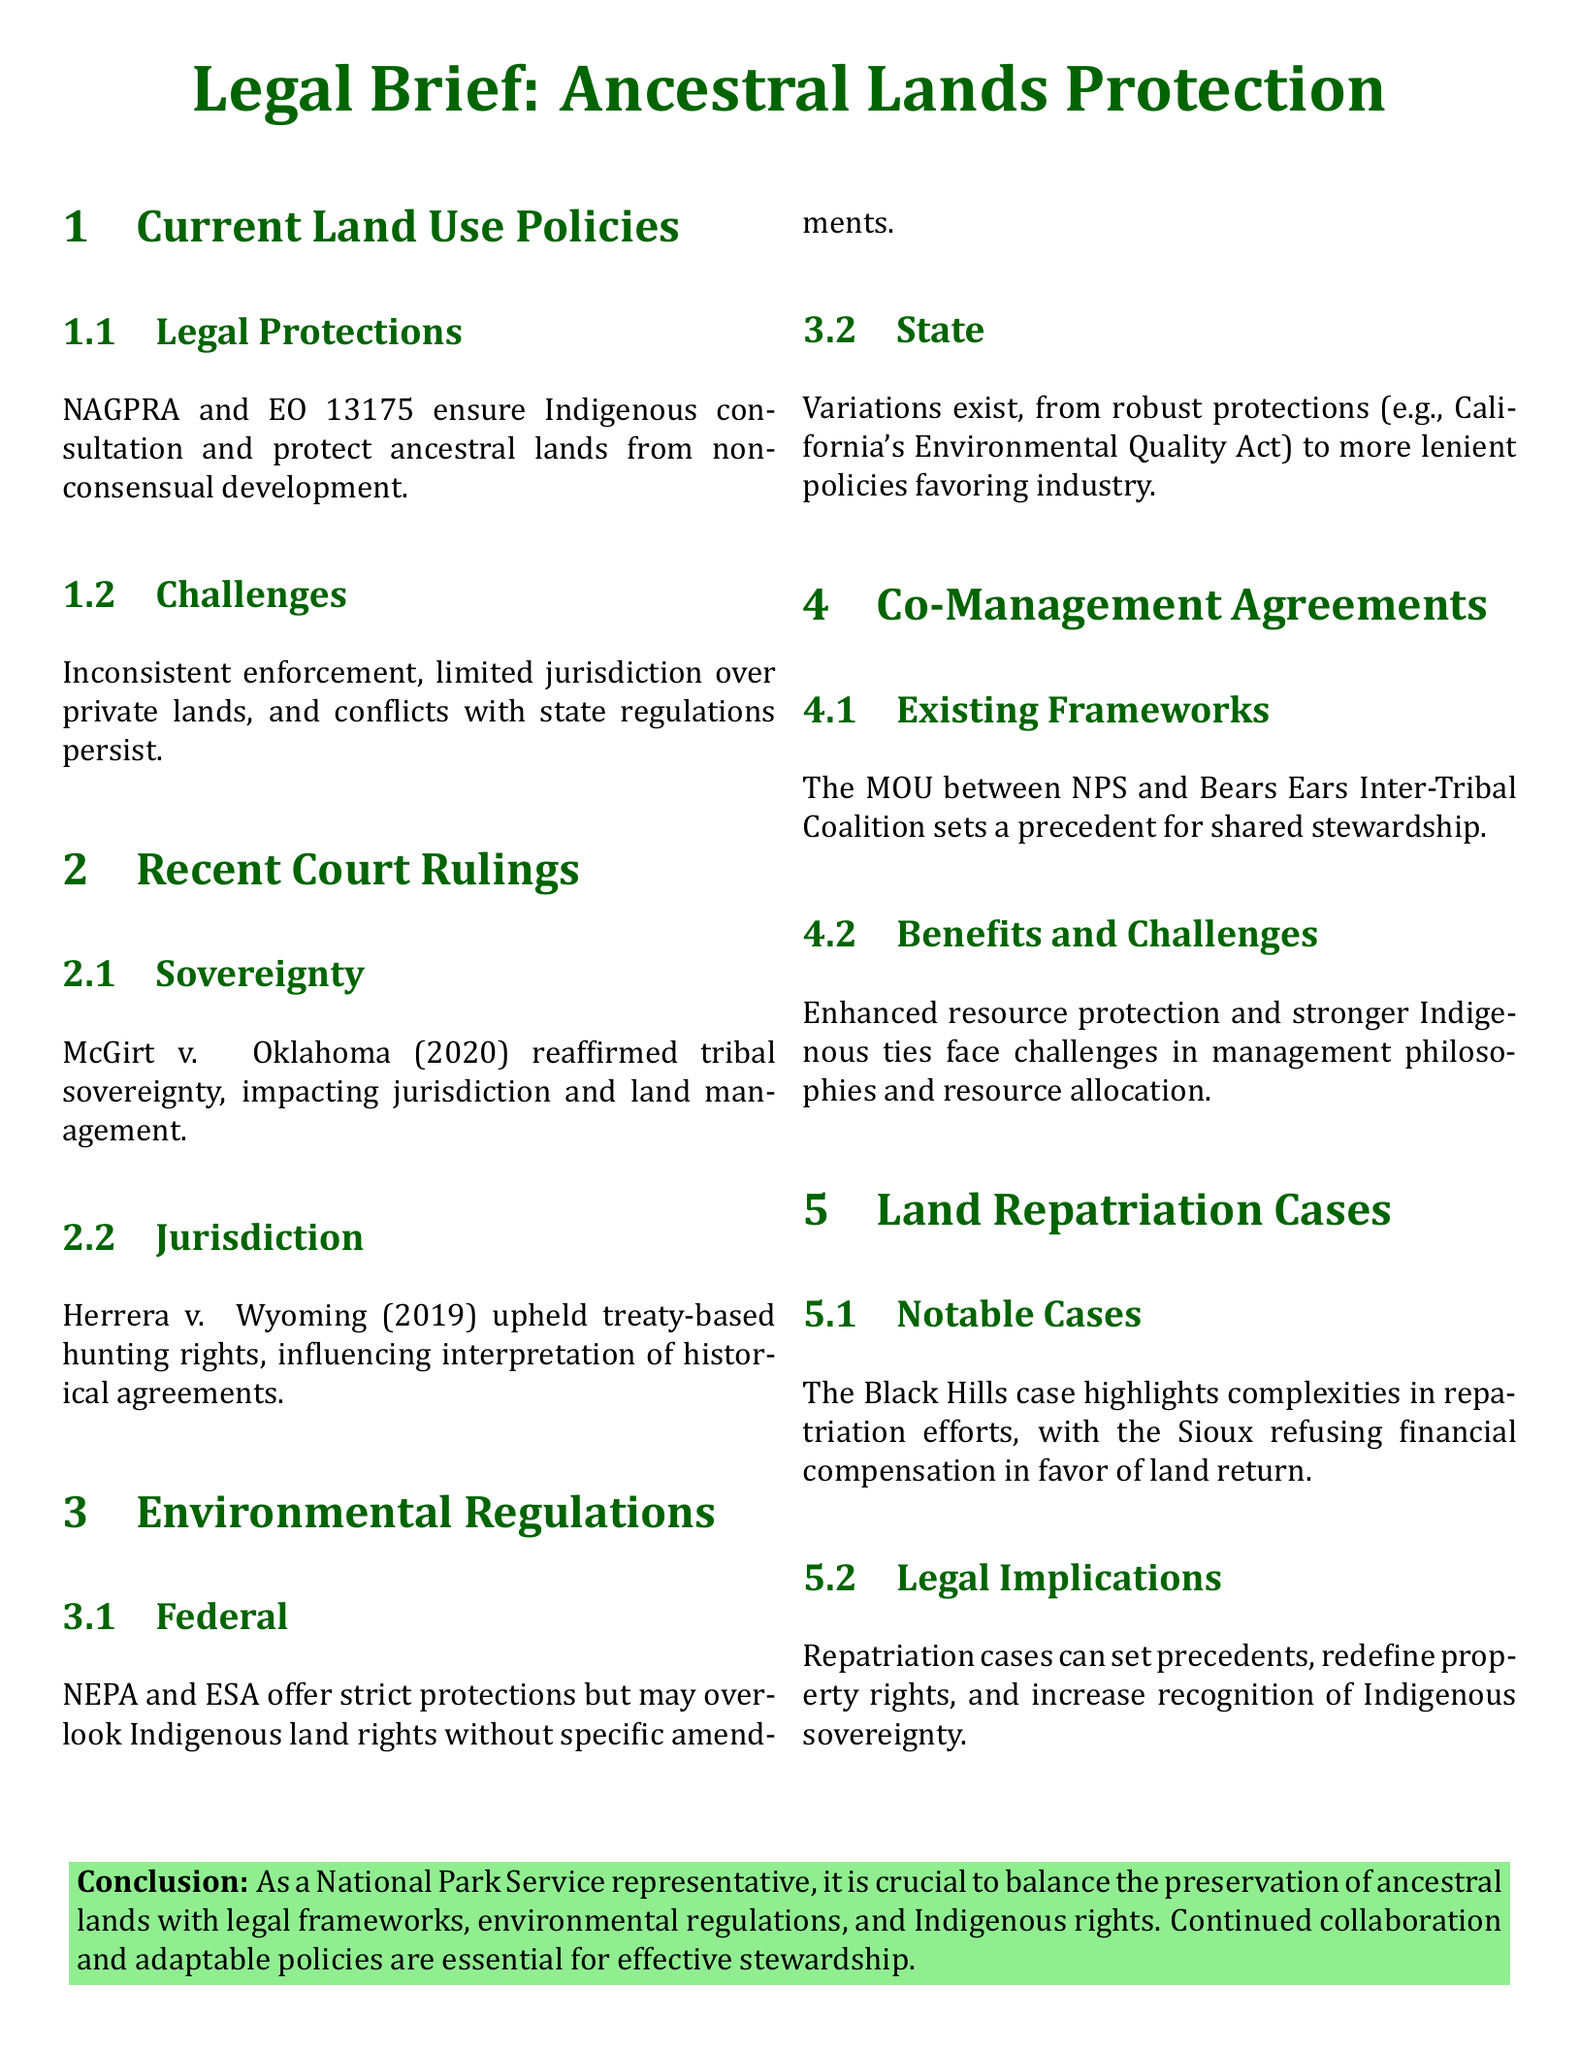What are the two legal frameworks ensuring protection of ancestral lands? The document mentions NAGPRA and EO 13175 as the legal frameworks ensuring protection.
Answer: NAGPRA and EO 13175 What case reaffirmed tribal sovereignty? The document cites McGirt v. Oklahoma (2020) as the case that reaffirmed tribal sovereignty.
Answer: McGirt v. Oklahoma (2020) Which act may overlook Indigenous land rights? The National Environmental Policy Act (NEPA) is noted for potentially overlooking Indigenous land rights without amendments.
Answer: NEPA What is the notable case involving the Black Hills? The Black Hills case is highlighted in the document regarding repatriation efforts.
Answer: Black Hills case What agreement sets a precedent for shared stewardship? The MOU between NPS and Bears Ears Inter-Tribal Coalition is referenced as a precedent for shared stewardship.
Answer: MOU between NPS and Bears Ears Inter-Tribal Coalition What challenge is mentioned regarding co-management agreements? The document mentions challenges in management philosophies and resource allocation relating to co-management agreements.
Answer: Management philosophies and resource allocation What does EO 13175 emphasize? EO 13175 emphasizes Indigenous consultation in relation to land use policies.
Answer: Indigenous consultation Which law provides strict protections but may lack specific amendments for Indigenous rights? The Environmental Species Act (ESA) is noted for providing strict protections but may lack specific amendments for Indigenous rights.
Answer: ESA 